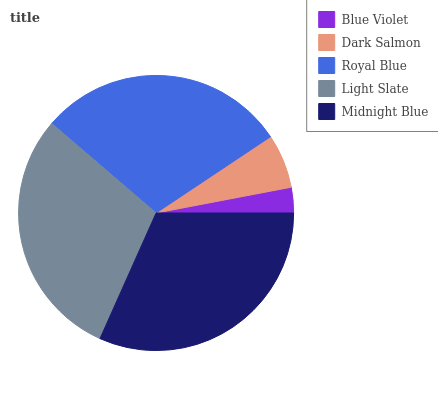Is Blue Violet the minimum?
Answer yes or no. Yes. Is Midnight Blue the maximum?
Answer yes or no. Yes. Is Dark Salmon the minimum?
Answer yes or no. No. Is Dark Salmon the maximum?
Answer yes or no. No. Is Dark Salmon greater than Blue Violet?
Answer yes or no. Yes. Is Blue Violet less than Dark Salmon?
Answer yes or no. Yes. Is Blue Violet greater than Dark Salmon?
Answer yes or no. No. Is Dark Salmon less than Blue Violet?
Answer yes or no. No. Is Royal Blue the high median?
Answer yes or no. Yes. Is Royal Blue the low median?
Answer yes or no. Yes. Is Dark Salmon the high median?
Answer yes or no. No. Is Blue Violet the low median?
Answer yes or no. No. 